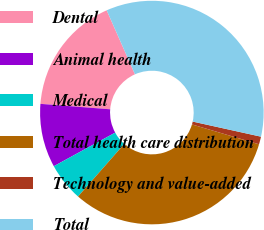Convert chart to OTSL. <chart><loc_0><loc_0><loc_500><loc_500><pie_chart><fcel>Dental<fcel>Animal health<fcel>Medical<fcel>Total health care distribution<fcel>Technology and value-added<fcel>Total<nl><fcel>17.14%<fcel>9.21%<fcel>5.55%<fcel>31.9%<fcel>1.12%<fcel>35.09%<nl></chart> 